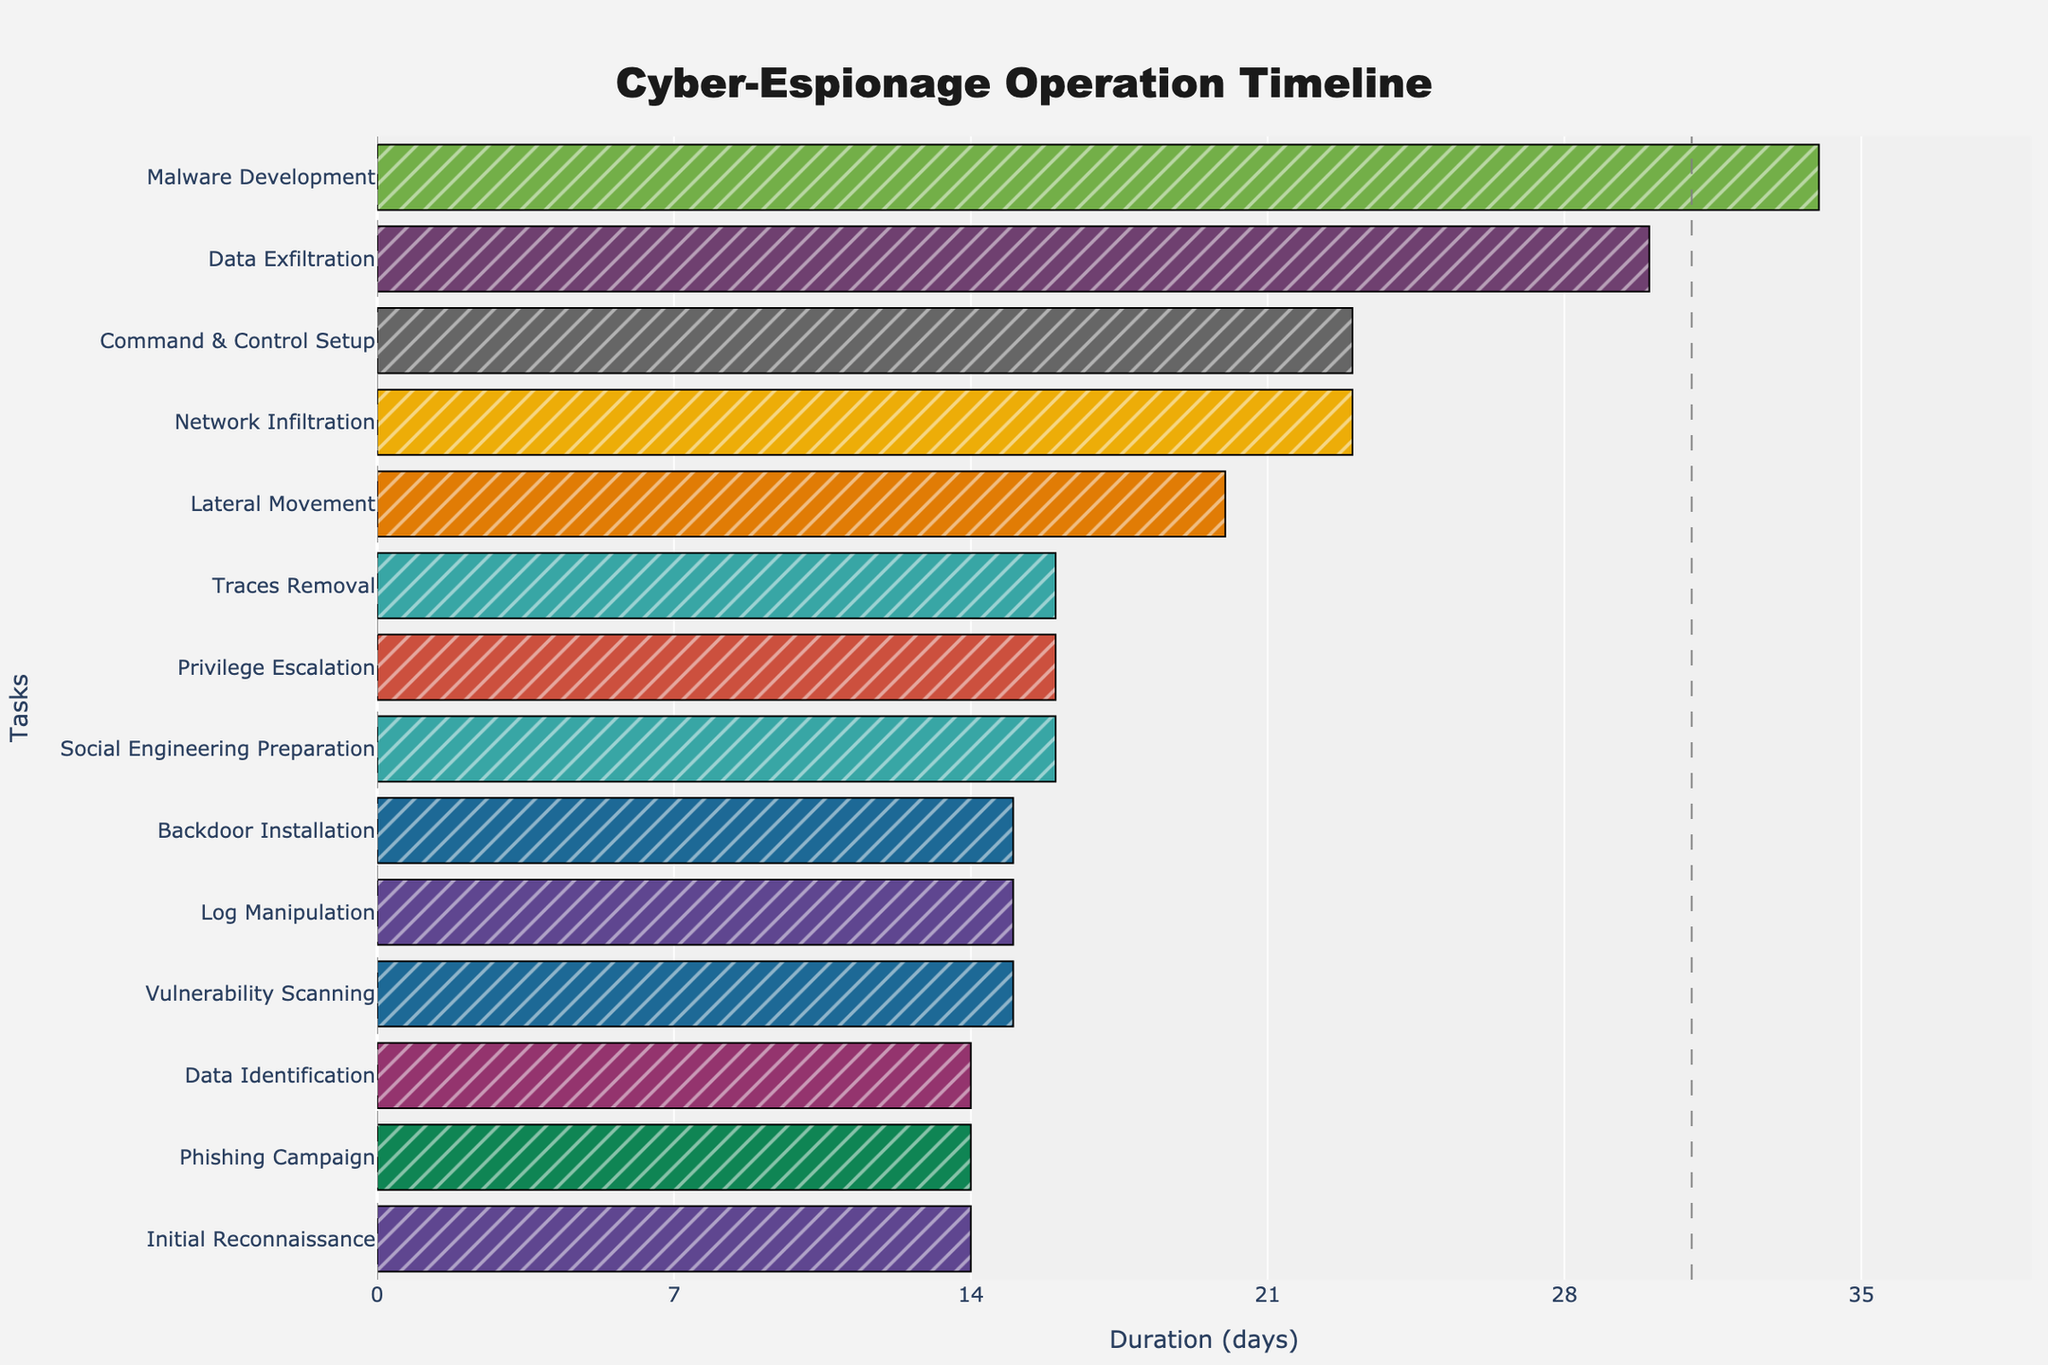Which task has the longest duration? To find the task with the longest duration, look at the length of the bars; the longer the bar, the longer the task duration.
Answer: Malware Development What's the total duration for the "Data Exfiltration" task? Refer to the "Data Exfiltration" bar and check its duration in days.
Answer: 30 days Which two tasks overlap the most? To determine the two tasks that overlap the most, find the bars that have the most significant range of overlapping dates.
Answer: Network Infiltration and Command & Control Setup How many tasks were active during March 2023? Scan the Gantt chart for tasks that span over March 2023. Count each relevant bar.
Answer: 4 Which task ends first in February 2023? Identify tasks ending in February 2023 and find which one has the earliest end date.
Answer: Phishing Campaign What is the duration between the start of "Initial Reconnaissance" and the end of "Traces Removal"? Calculate the days between the start date of "Initial Reconnaissance" and the end date of "Traces Removal".
Answer: From Jan 1, 2023, to Jun 10, 2023, which is 161 days Which task starts immediately after "Lateral Movement"? To find the task that starts immediately after "Lateral Movement", note its end date and identify the next task by its start date.
Answer: Privilege Escalation What is the shortest task duration on this chart? Find the shortest bar, which represents the task with the fewest days.
Answer: 10 days (Log Manipulation) Which phase encompasses "Network Infiltration" and "Privilege Escalation"? Determine which overarching phases these tasks belong to by their nature; these activities are part of the infiltration and post-infiltration phase.
Answer: Infiltration What is the overall duration of phases with data exfiltration activities? Look at the tasks related to reconnaissance, identifying, and exfiltrating data, and sum up the overlaps for "Data Identification" and "Data Exfiltration".
Answer: 44 days (15 days for Data Identification + 30 overlapping 5 days for Data Exfiltration) 